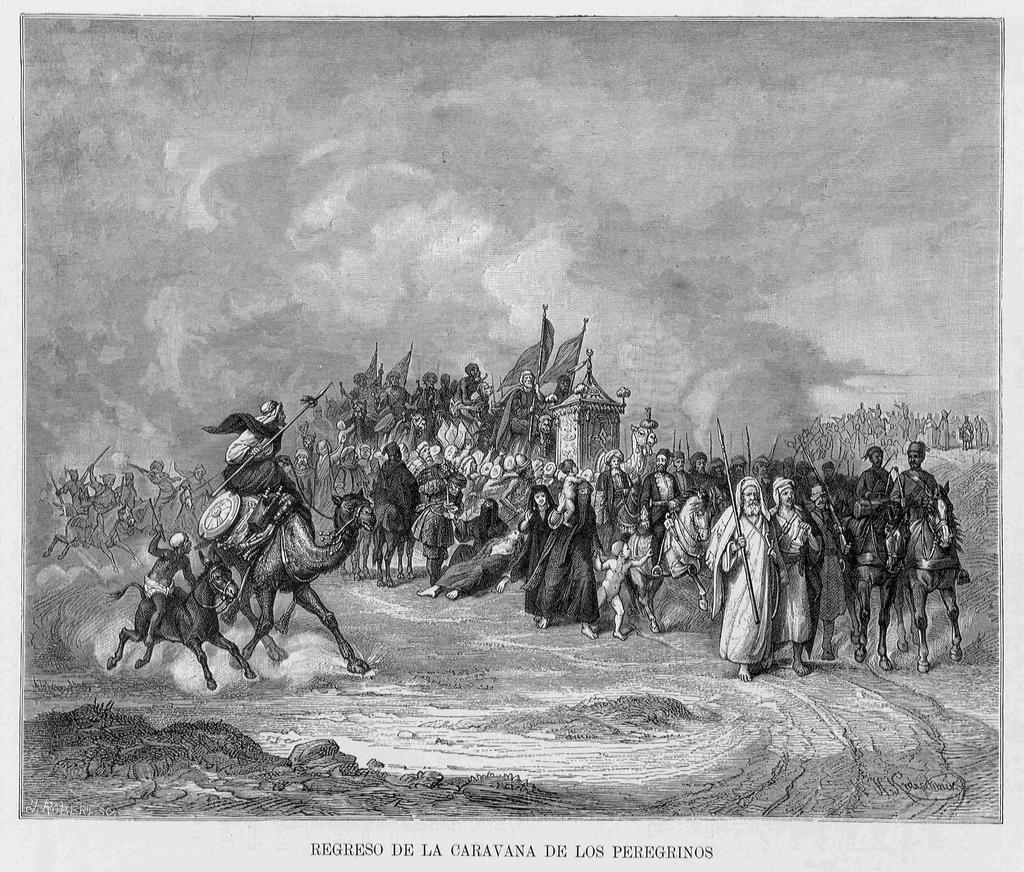Please provide a concise description of this image. In this picture, we can see an image of a few people, we can see some animals, some objects in people's hand, and we can see the ground, sky and some label in the bottom of an image. 